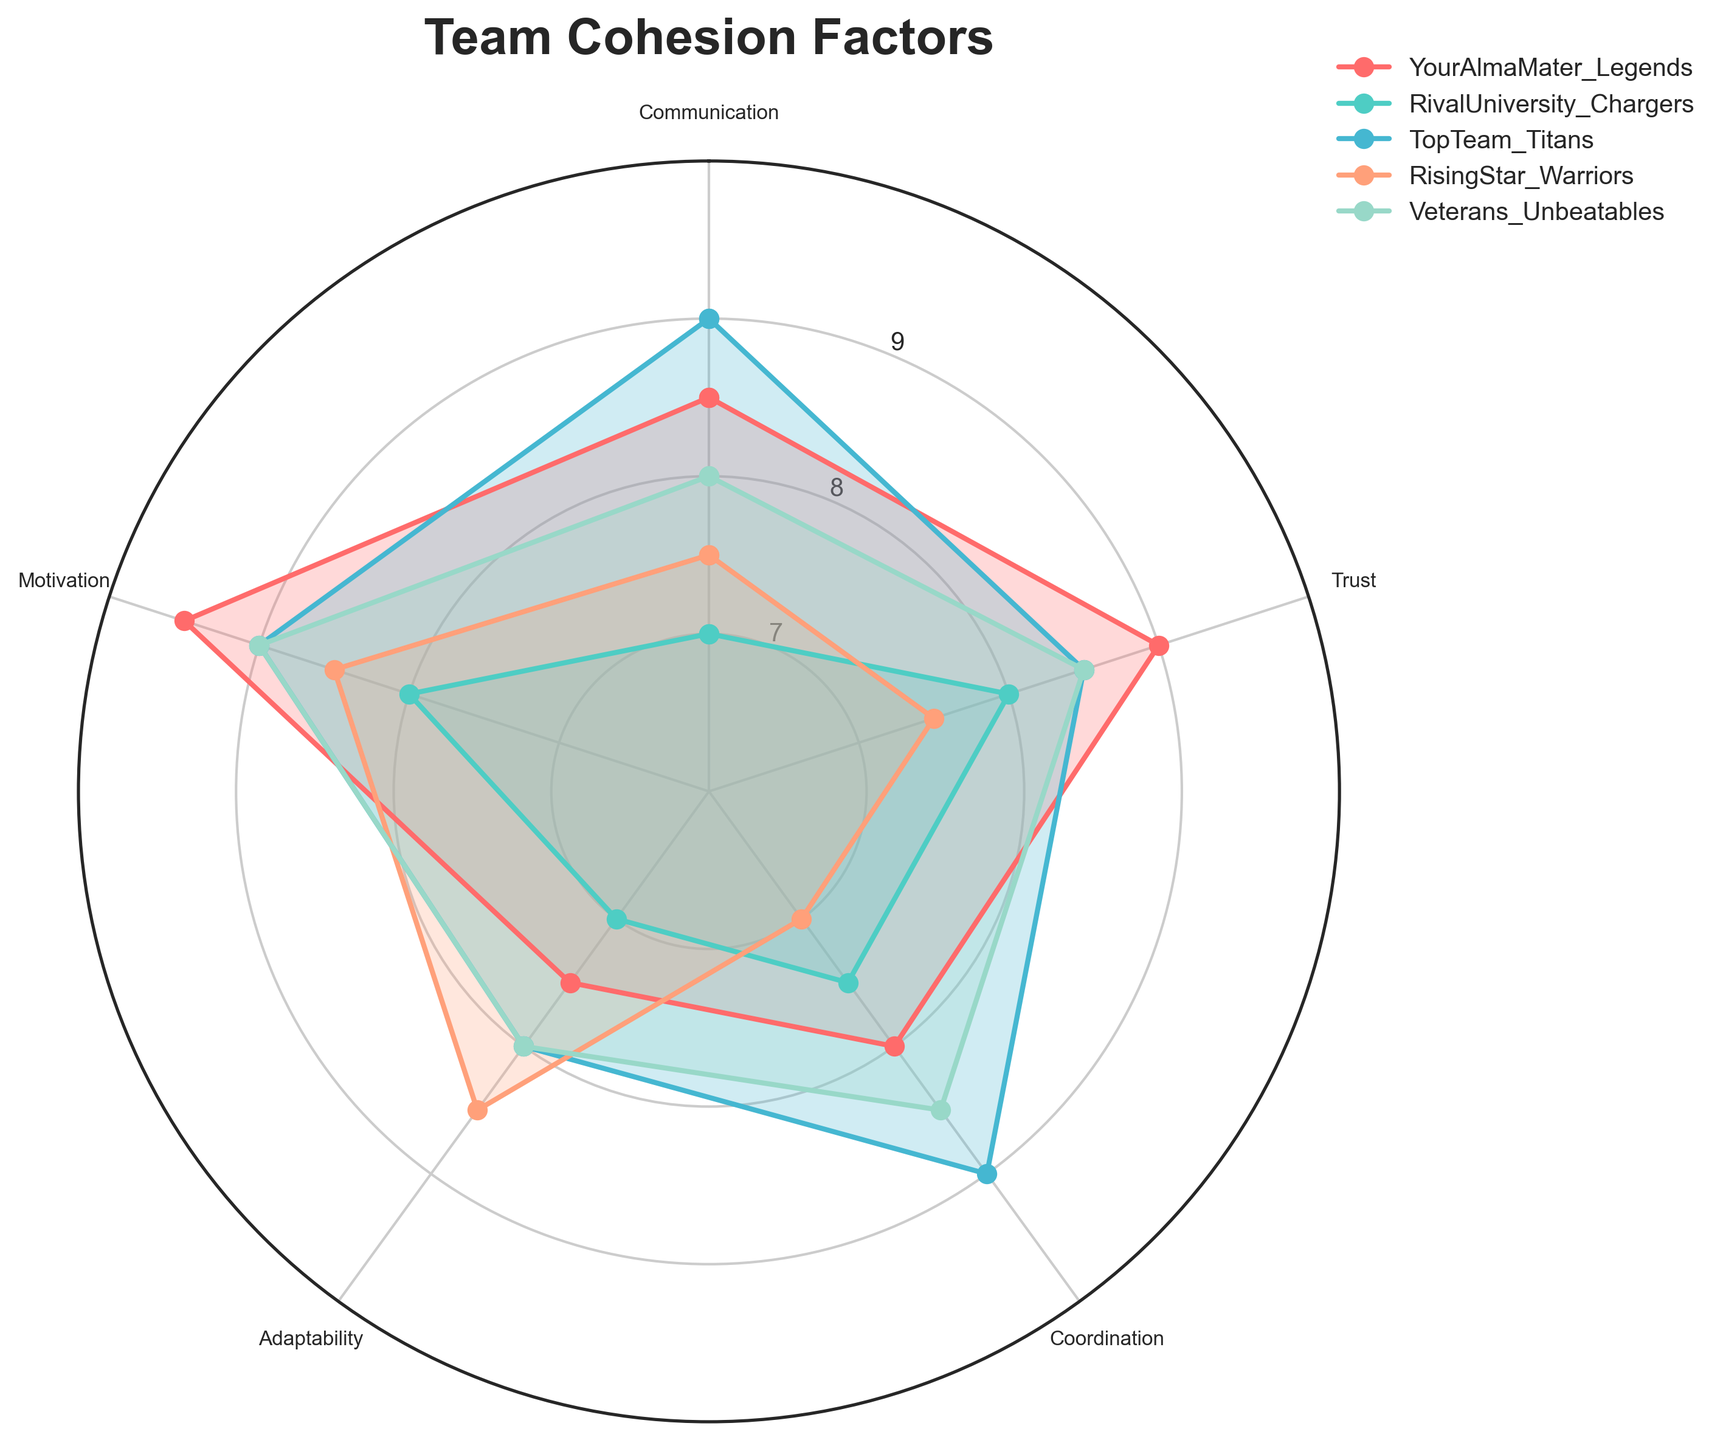What's the title of the radar chart? The title is usually at the top of the radar chart. Reading it directly gives "Team Cohesion Factors".
Answer: Team Cohesion Factors Which team has the highest score in Communication? By looking at the Communication value for each team, the TopTeam_Titans have the highest score of 9.0.
Answer: TopTeam_Titans How do the Trust scores compare between YourAlmaMater_Legends and RivalUniversity_Chargers? YourAlmaMater_Legends has a Trust score of 9.0 while the RivalUniversity_Chargers has a Trust score of 8.0. 9.0 is greater than 8.0.
Answer: YourAlmaMater_Legends has a higher Trust score than RivalUniversity_Chargers Which team has the lowest score in any single factor, and what is the factor? Scanning through all the team scores across the factors, RivalUniversity_Chargers have the lowest score of 7.0 in both Communication and Adaptability.
Answer: RivalUniversity_Chargers, Communication and Adaptability What is the average Adaptability score for all teams? Summing up the Adaptability scores (7.5 + 7.0 + 8.0 + 8.5 + 8.0) gives 39.0. Dividing by the number of teams (5) gives an average of 7.8.
Answer: 7.8 In which factor do YourAlmaMater_Legends and TopTeam_Titans tie? Comparing each factor individually, both teams score 9.0 in Trust.
Answer: Trust Which team shows the highest overall cohesion by considering the sum of all factors? Summing the scores for each team, TopTeam_Titans score highest with (9.0 + 8.5 + 9.0 + 8.0 + 9.0) = 43.5, indicating the highest overall cohesion.
Answer: TopTeam_Titans Are there any factors where RisingStar_Warriors excel compared to Veterans_Unbeatables? Comparing the scores for each factor, RisingStar_Warriors have a higher score in Adaptability (8.5 vs. 8.0).
Answer: Yes, in Adaptability Which category has the most balanced score distribution? Viewing the spread of values, Veterans_Unbeatables have scores ranging from 8.0 to 9.0, indicating a more balanced distribution.
Answer: Veterans_Unbeatables 